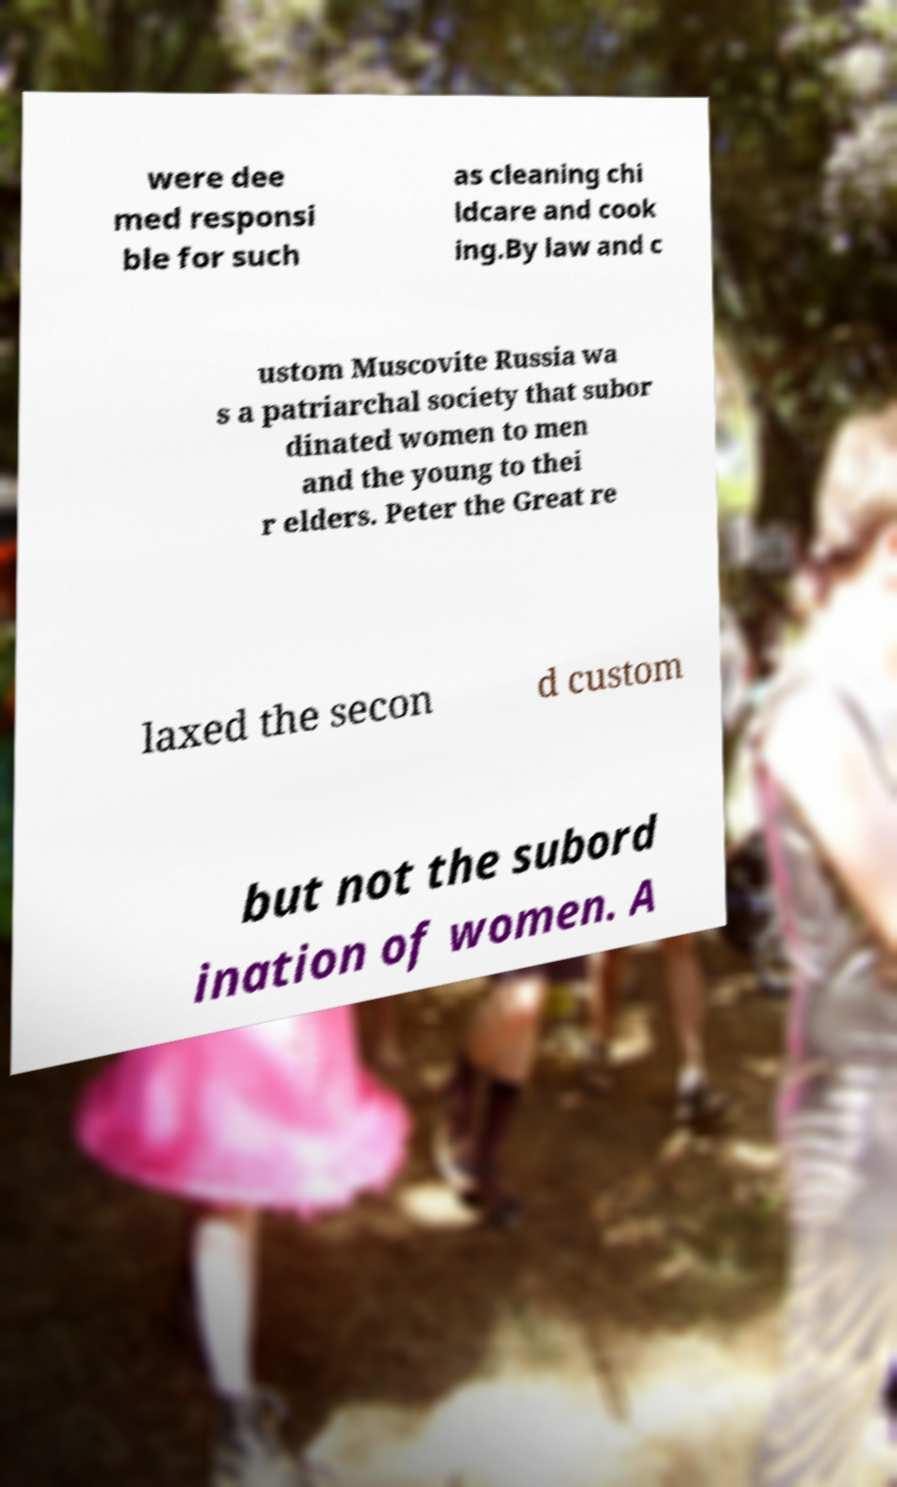What messages or text are displayed in this image? I need them in a readable, typed format. were dee med responsi ble for such as cleaning chi ldcare and cook ing.By law and c ustom Muscovite Russia wa s a patriarchal society that subor dinated women to men and the young to thei r elders. Peter the Great re laxed the secon d custom but not the subord ination of women. A 